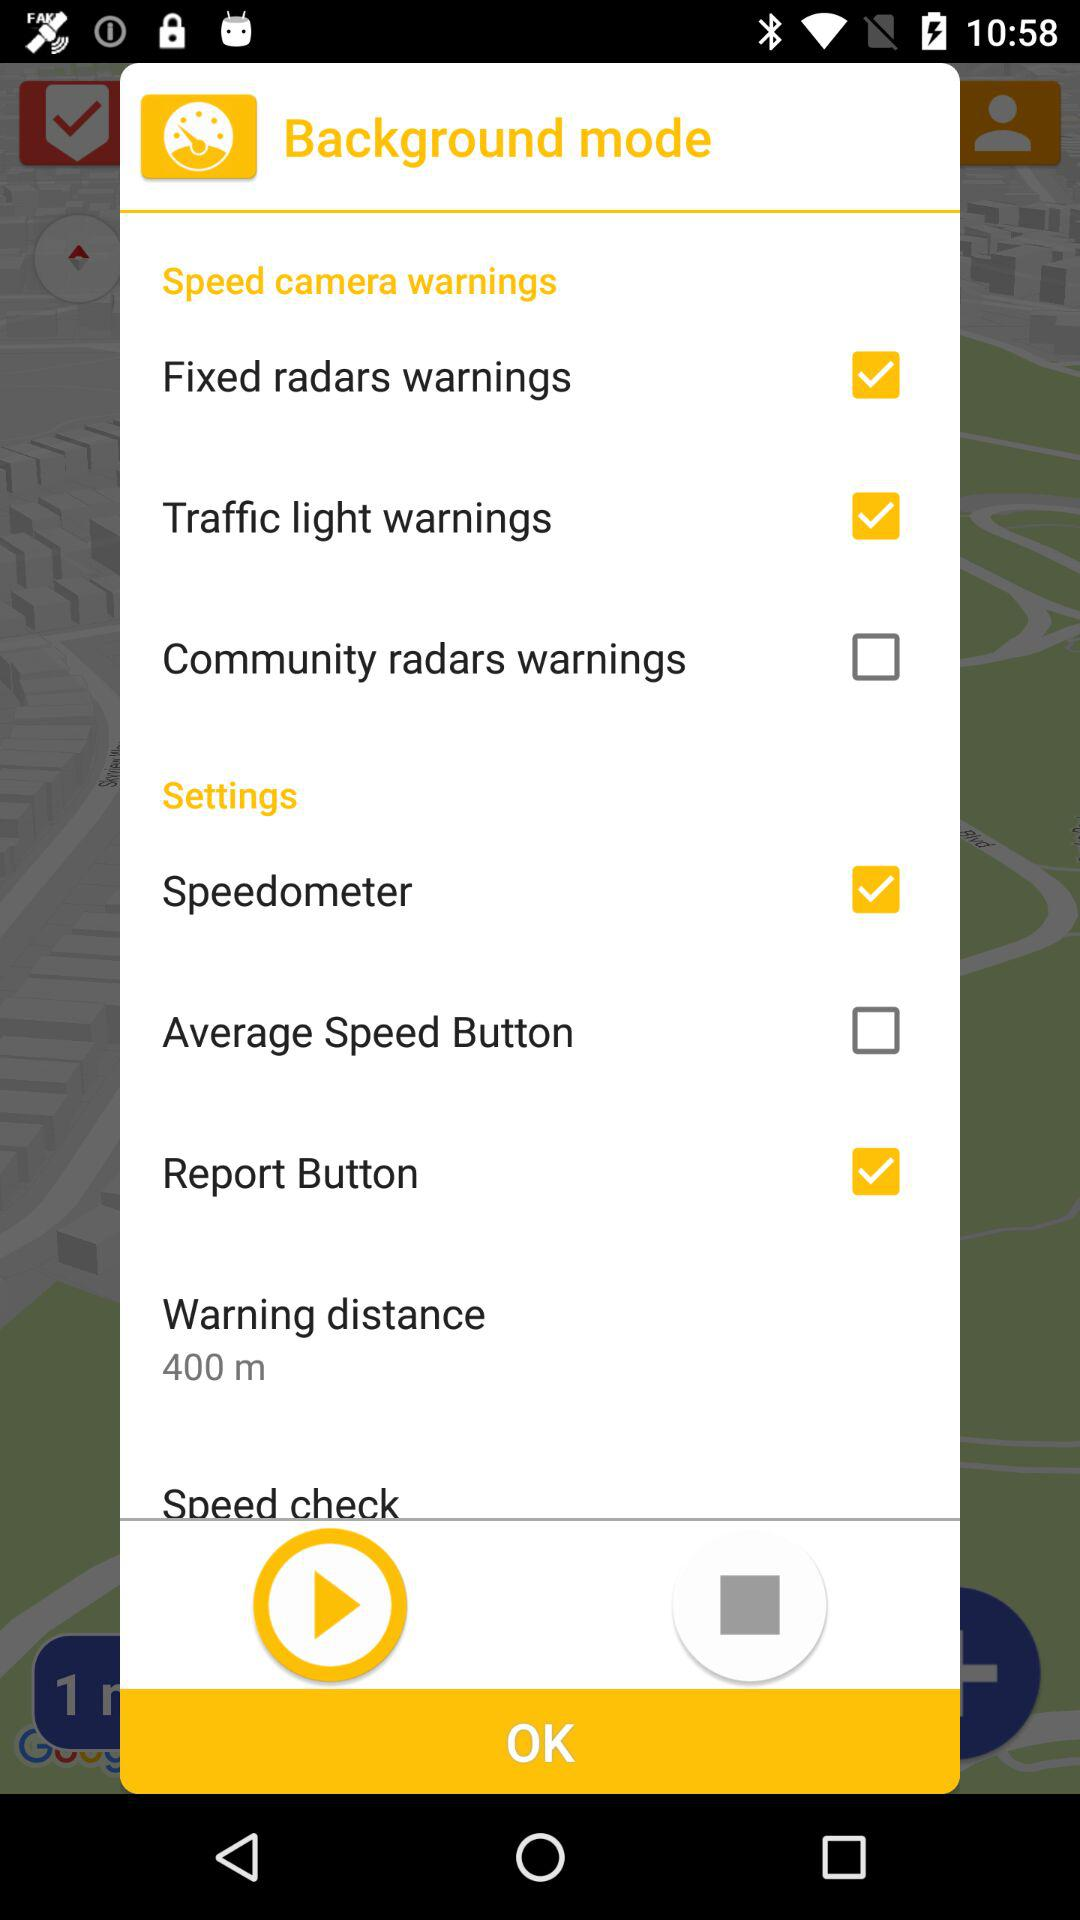Which options are selected in "Speed camera warnings"? The selected options are "Fixed radars warnings" and "Traffic light warnings". 